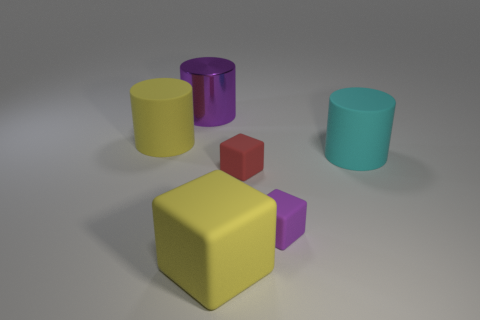Add 4 large blue matte objects. How many objects exist? 10 Add 6 metal things. How many metal things are left? 7 Add 6 tiny blue rubber cylinders. How many tiny blue rubber cylinders exist? 6 Subtract 0 purple spheres. How many objects are left? 6 Subtract all matte cylinders. Subtract all big yellow rubber cylinders. How many objects are left? 3 